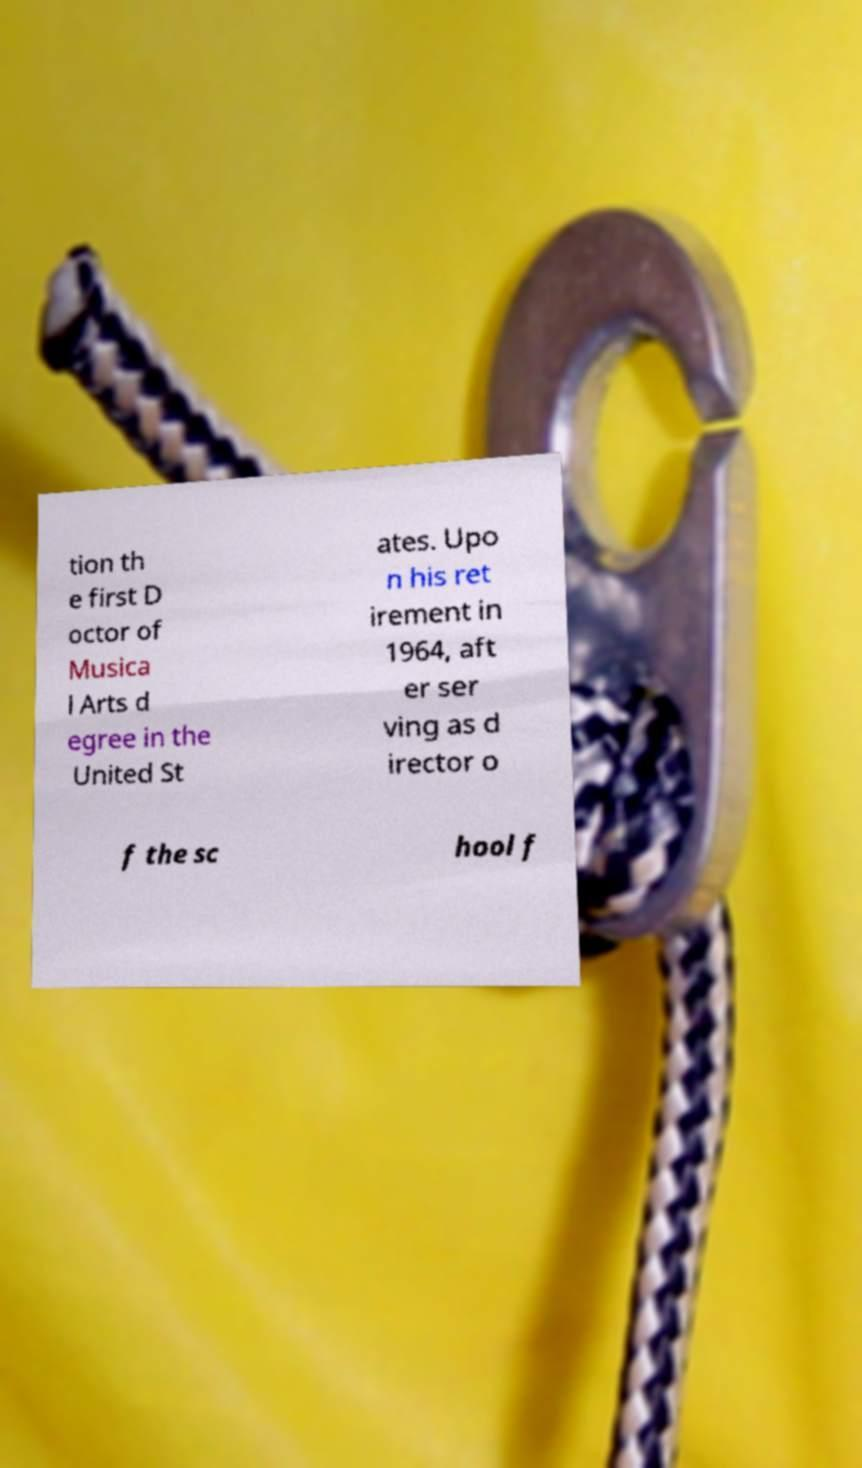There's text embedded in this image that I need extracted. Can you transcribe it verbatim? tion th e first D octor of Musica l Arts d egree in the United St ates. Upo n his ret irement in 1964, aft er ser ving as d irector o f the sc hool f 